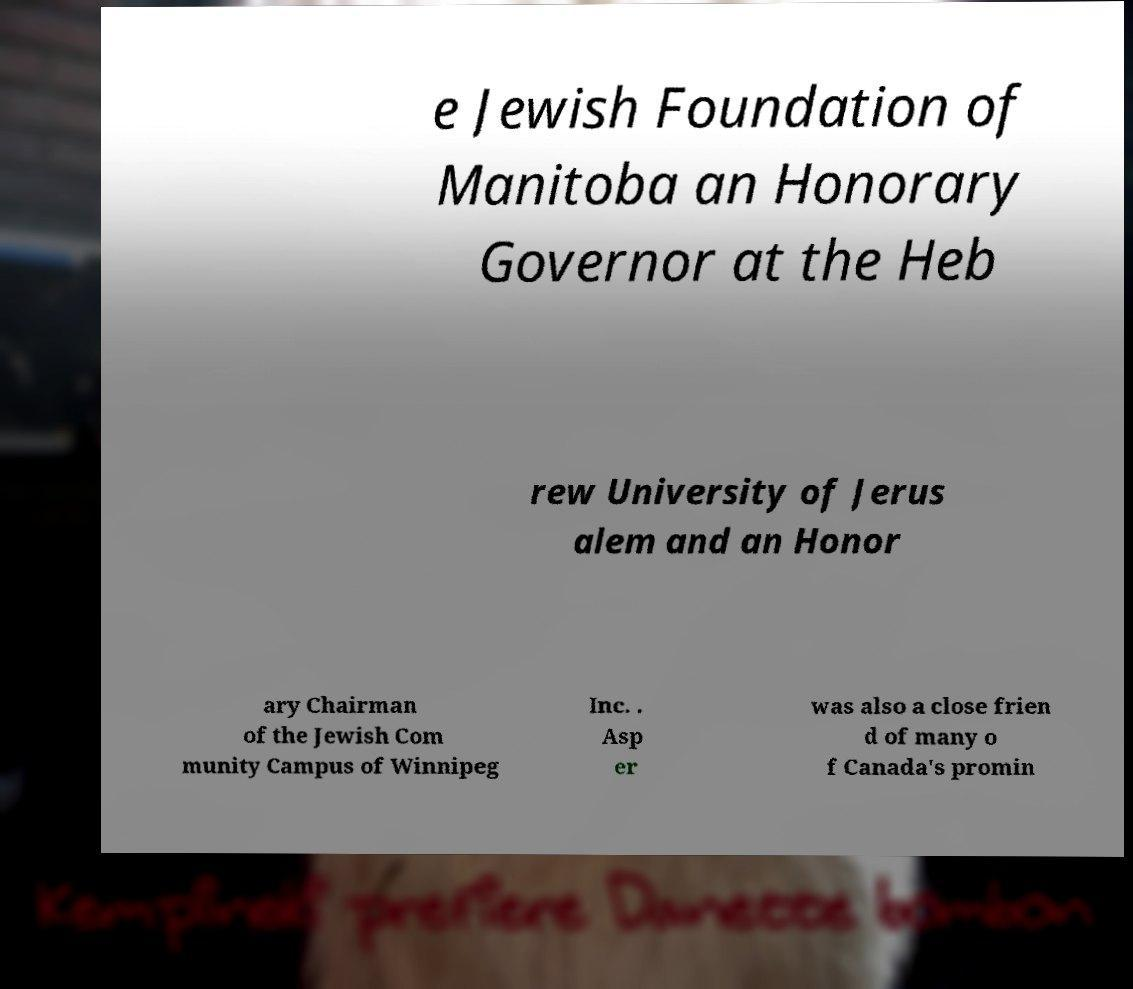Can you accurately transcribe the text from the provided image for me? e Jewish Foundation of Manitoba an Honorary Governor at the Heb rew University of Jerus alem and an Honor ary Chairman of the Jewish Com munity Campus of Winnipeg Inc. . Asp er was also a close frien d of many o f Canada's promin 